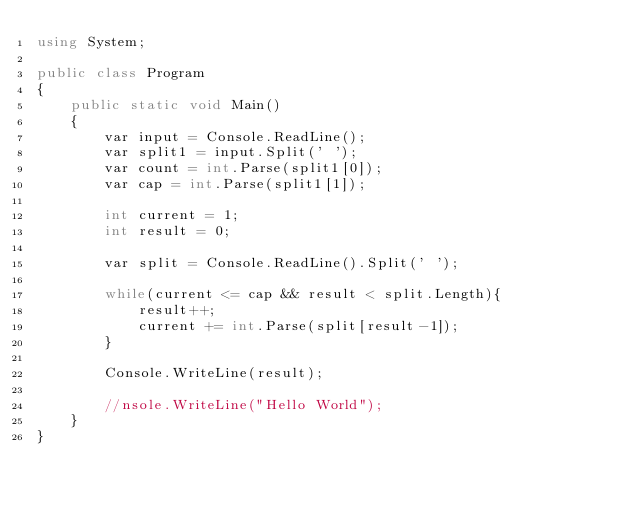<code> <loc_0><loc_0><loc_500><loc_500><_C#_>using System;
					
public class Program
{
	public static void Main()
	{
		var input = Console.ReadLine();
		var split1 = input.Split(' ');
		var count = int.Parse(split1[0]);
		var cap = int.Parse(split1[1]);
		
		int current = 1;
		int result = 0;
		
		var split = Console.ReadLine().Split(' ');
		
		while(current <= cap && result < split.Length){
			result++;
			current += int.Parse(split[result-1]);
		}
		
		Console.WriteLine(result);
		
		//nsole.WriteLine("Hello World");
	}
}</code> 